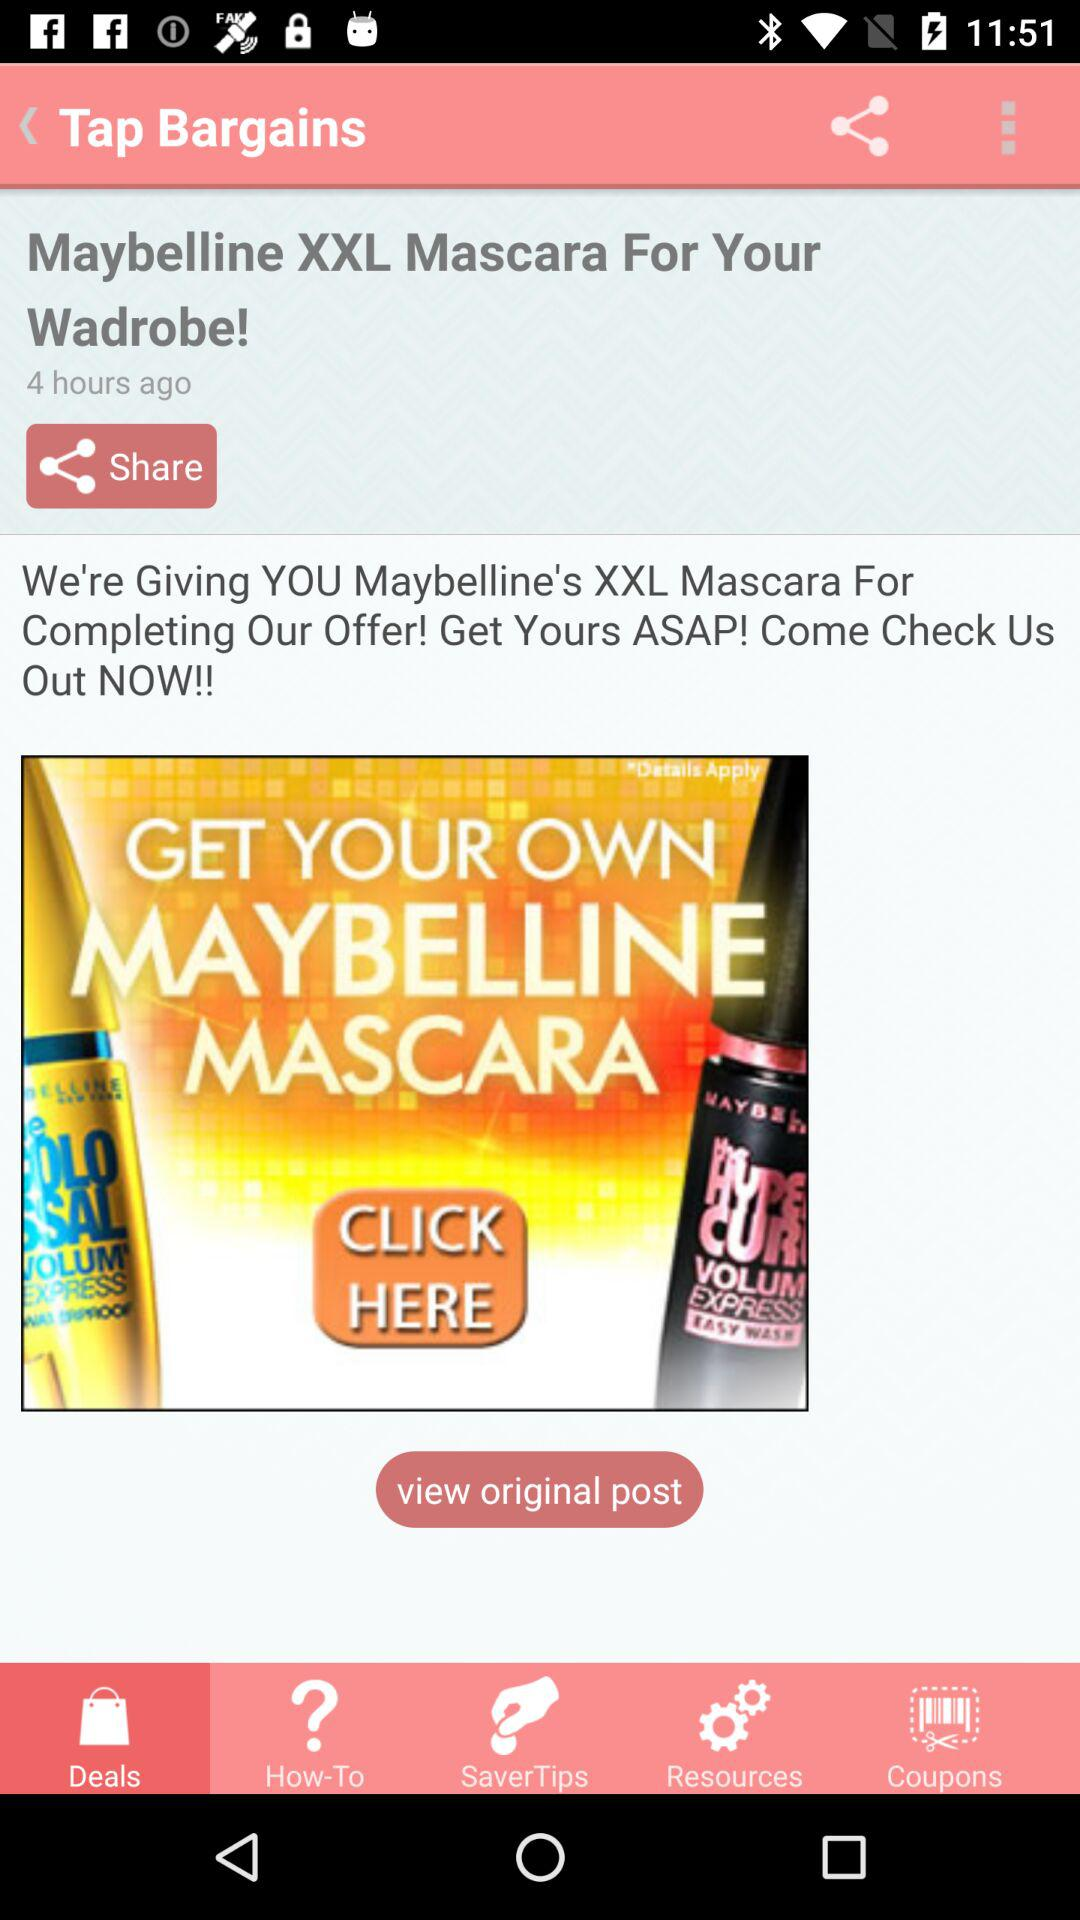How many hours ago was the "Maybelline XXL Mascara" product posted? The "Maybelline XXL Mascara" product was posted 4 hours ago. 